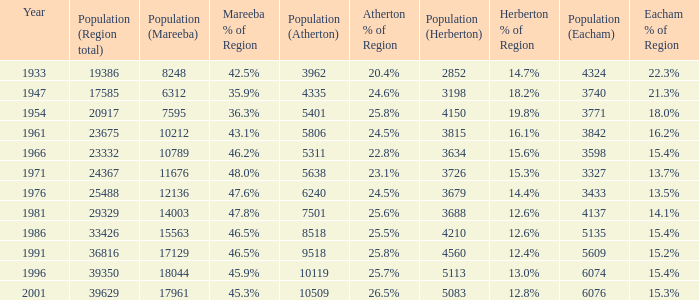What was the lowest population statistic for mareeba? 6312.0. 